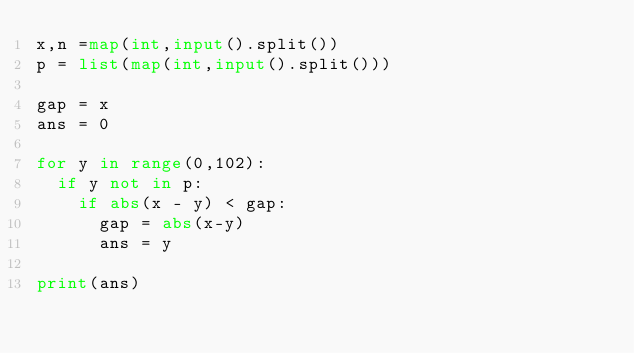<code> <loc_0><loc_0><loc_500><loc_500><_Python_>x,n =map(int,input().split())
p = list(map(int,input().split()))

gap = x
ans = 0

for y in range(0,102):
  if y not in p:
    if abs(x - y) < gap:
      gap = abs(x-y)
      ans = y
      
print(ans)
    </code> 